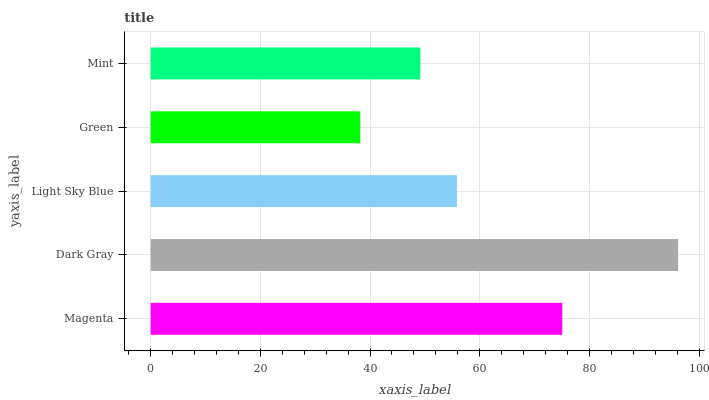Is Green the minimum?
Answer yes or no. Yes. Is Dark Gray the maximum?
Answer yes or no. Yes. Is Light Sky Blue the minimum?
Answer yes or no. No. Is Light Sky Blue the maximum?
Answer yes or no. No. Is Dark Gray greater than Light Sky Blue?
Answer yes or no. Yes. Is Light Sky Blue less than Dark Gray?
Answer yes or no. Yes. Is Light Sky Blue greater than Dark Gray?
Answer yes or no. No. Is Dark Gray less than Light Sky Blue?
Answer yes or no. No. Is Light Sky Blue the high median?
Answer yes or no. Yes. Is Light Sky Blue the low median?
Answer yes or no. Yes. Is Mint the high median?
Answer yes or no. No. Is Mint the low median?
Answer yes or no. No. 